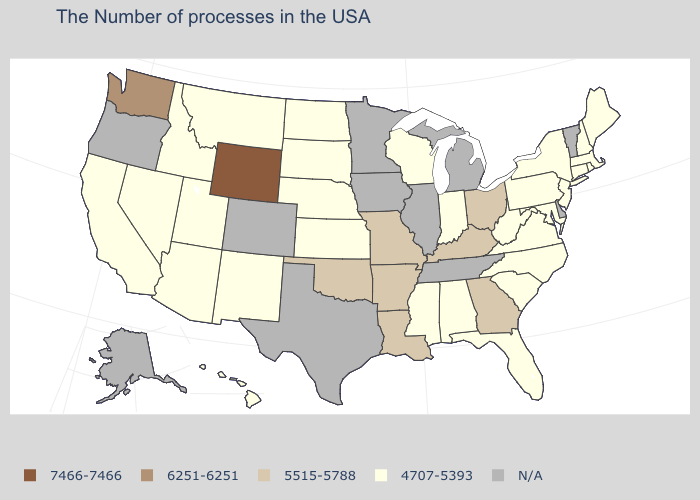Which states have the lowest value in the USA?
Write a very short answer. Maine, Massachusetts, Rhode Island, New Hampshire, Connecticut, New York, New Jersey, Maryland, Pennsylvania, Virginia, North Carolina, South Carolina, West Virginia, Florida, Indiana, Alabama, Wisconsin, Mississippi, Kansas, Nebraska, South Dakota, North Dakota, New Mexico, Utah, Montana, Arizona, Idaho, Nevada, California, Hawaii. What is the value of New Jersey?
Short answer required. 4707-5393. Which states hav the highest value in the Northeast?
Write a very short answer. Maine, Massachusetts, Rhode Island, New Hampshire, Connecticut, New York, New Jersey, Pennsylvania. Name the states that have a value in the range 6251-6251?
Keep it brief. Washington. Which states hav the highest value in the South?
Short answer required. Georgia, Kentucky, Louisiana, Arkansas, Oklahoma. What is the highest value in the USA?
Keep it brief. 7466-7466. Name the states that have a value in the range 5515-5788?
Short answer required. Ohio, Georgia, Kentucky, Louisiana, Missouri, Arkansas, Oklahoma. Which states have the lowest value in the USA?
Quick response, please. Maine, Massachusetts, Rhode Island, New Hampshire, Connecticut, New York, New Jersey, Maryland, Pennsylvania, Virginia, North Carolina, South Carolina, West Virginia, Florida, Indiana, Alabama, Wisconsin, Mississippi, Kansas, Nebraska, South Dakota, North Dakota, New Mexico, Utah, Montana, Arizona, Idaho, Nevada, California, Hawaii. What is the value of Florida?
Quick response, please. 4707-5393. Which states have the lowest value in the South?
Short answer required. Maryland, Virginia, North Carolina, South Carolina, West Virginia, Florida, Alabama, Mississippi. Which states have the highest value in the USA?
Give a very brief answer. Wyoming. Does the map have missing data?
Write a very short answer. Yes. What is the value of Oklahoma?
Concise answer only. 5515-5788. 